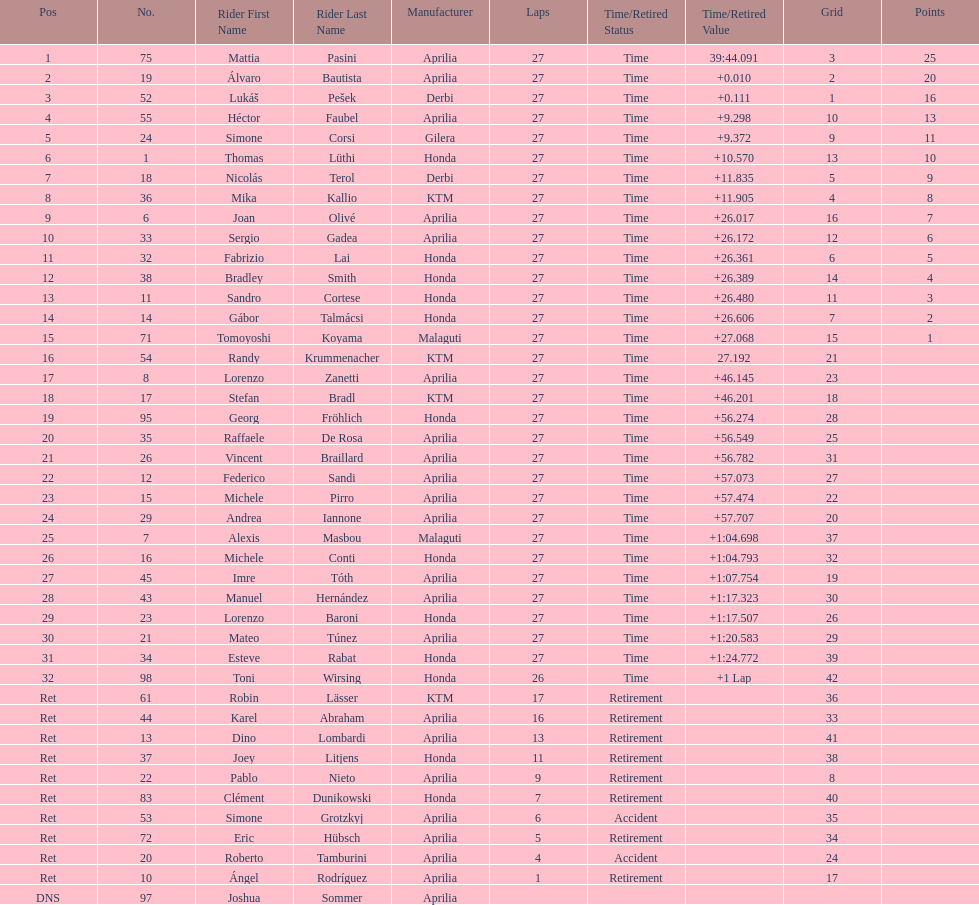Which rider came in first with 25 points? Mattia Pasini. 